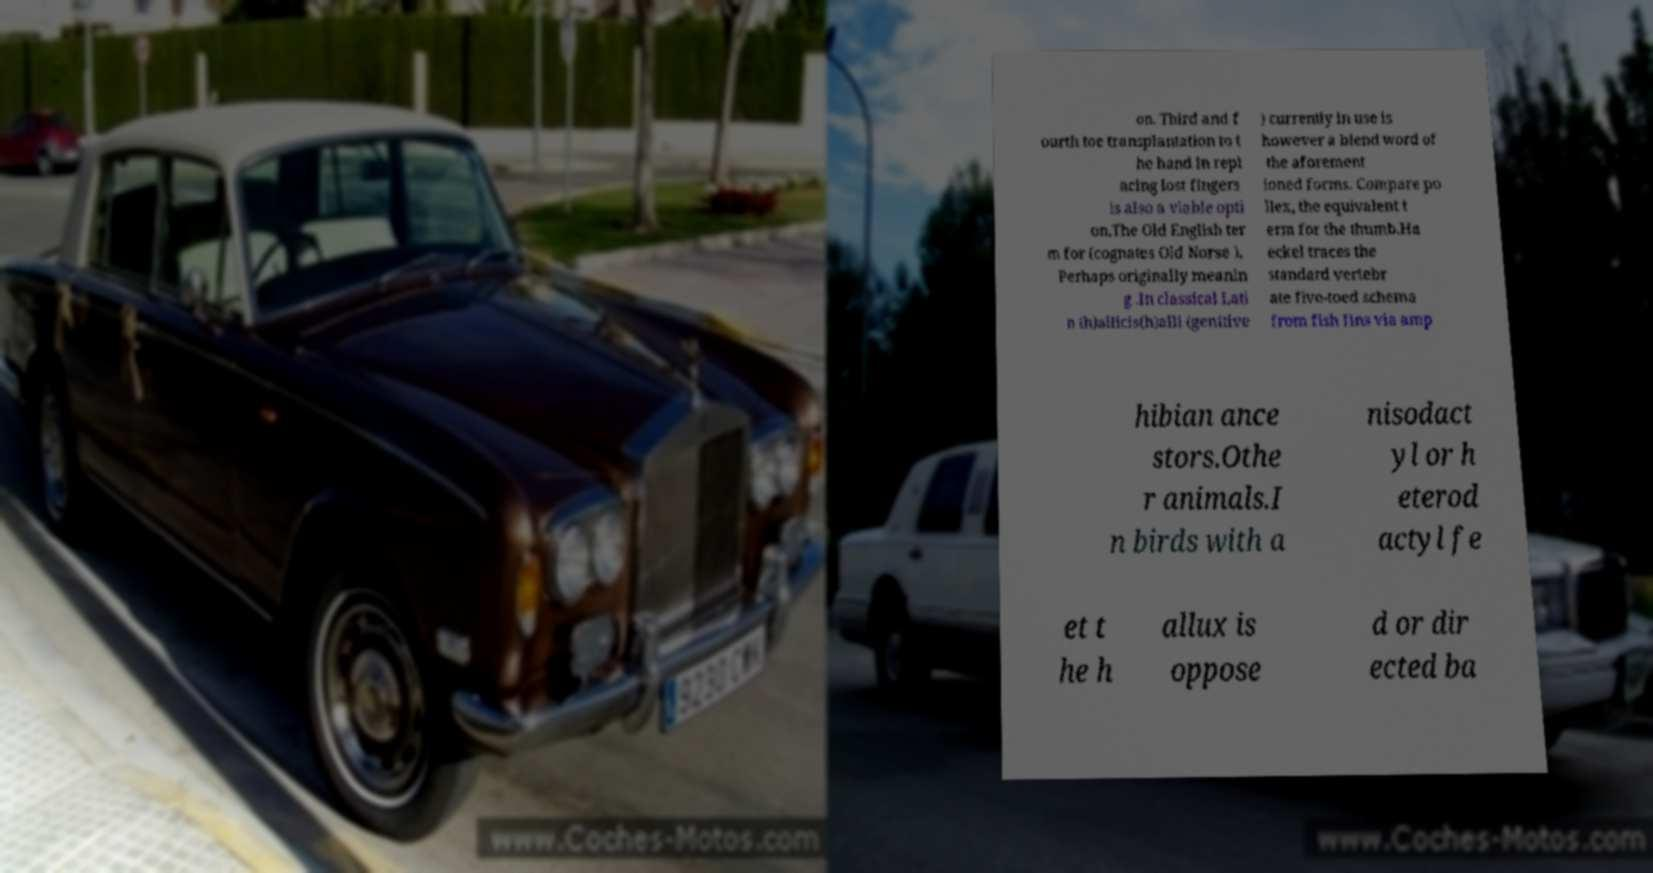What messages or text are displayed in this image? I need them in a readable, typed format. on. Third and f ourth toe transplantation to t he hand in repl acing lost fingers is also a viable opti on.The Old English ter m for (cognates Old Norse ). Perhaps originally meanin g .In classical Lati n (h)allicis(h)alli (genitive ) currently in use is however a blend word of the aforement ioned forms. Compare po llex, the equivalent t erm for the thumb.Ha eckel traces the standard vertebr ate five-toed schema from fish fins via amp hibian ance stors.Othe r animals.I n birds with a nisodact yl or h eterod actyl fe et t he h allux is oppose d or dir ected ba 